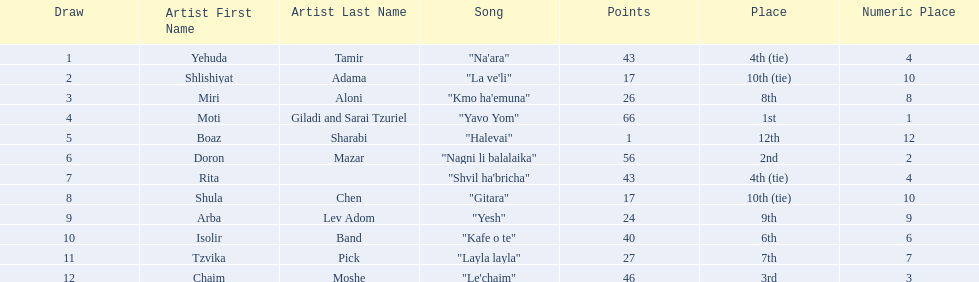Who were all the artists at the contest? Yehuda Tamir, Shlishiyat Adama, Miri Aloni, Moti Giladi and Sarai Tzuriel, Boaz Sharabi, Doron Mazar, Rita, Shula Chen, Arba Lev Adom, Isolir Band, Tzvika Pick, Chaim Moshe. What were their point totals? 43, 17, 26, 66, 1, 56, 43, 17, 24, 40, 27, 46. Of these, which is the least amount of points? 1. Which artists received this point total? Boaz Sharabi. 